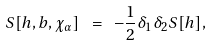Convert formula to latex. <formula><loc_0><loc_0><loc_500><loc_500>S [ h , b , \chi _ { \alpha } ] \ = \ - { \frac { 1 } { 2 } } \delta _ { 1 } \delta _ { 2 } S [ h ] ,</formula> 